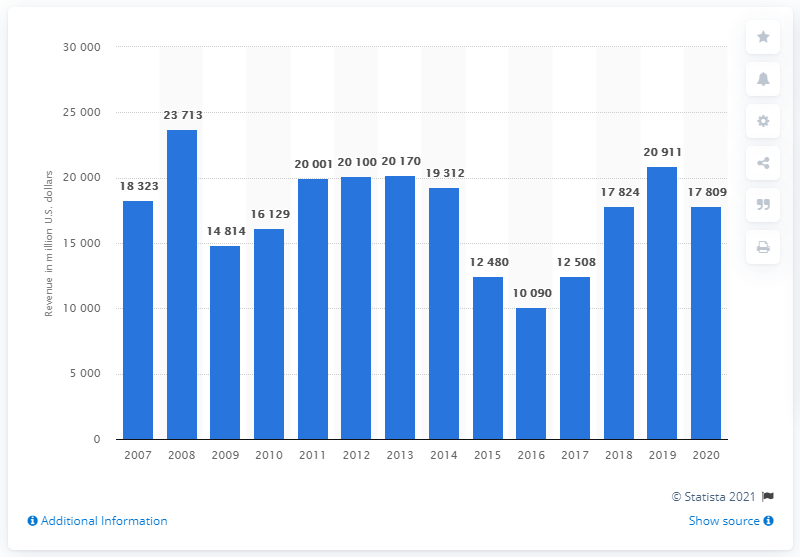Indicate a few pertinent items in this graphic. In 2020, the total revenue of Occidental Petroleum was 17,809 million dollars. In the year prior to the reporting period, Occidental Petroleum's revenue was 20,911. 